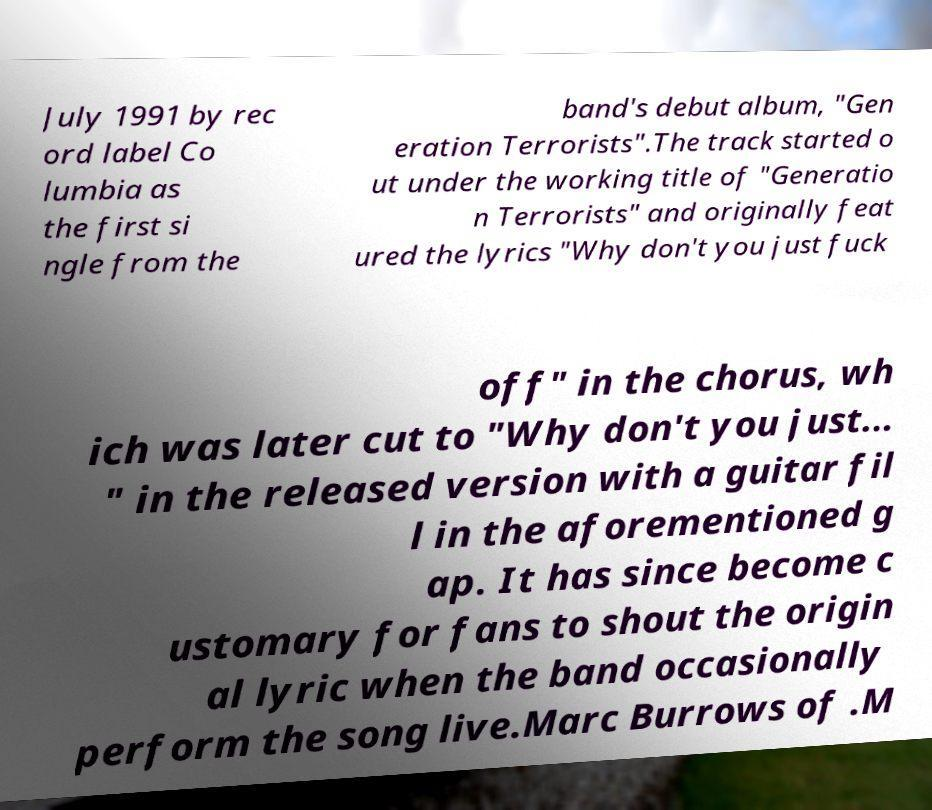Please identify and transcribe the text found in this image. July 1991 by rec ord label Co lumbia as the first si ngle from the band's debut album, "Gen eration Terrorists".The track started o ut under the working title of "Generatio n Terrorists" and originally feat ured the lyrics "Why don't you just fuck off" in the chorus, wh ich was later cut to "Why don't you just... " in the released version with a guitar fil l in the aforementioned g ap. It has since become c ustomary for fans to shout the origin al lyric when the band occasionally perform the song live.Marc Burrows of .M 